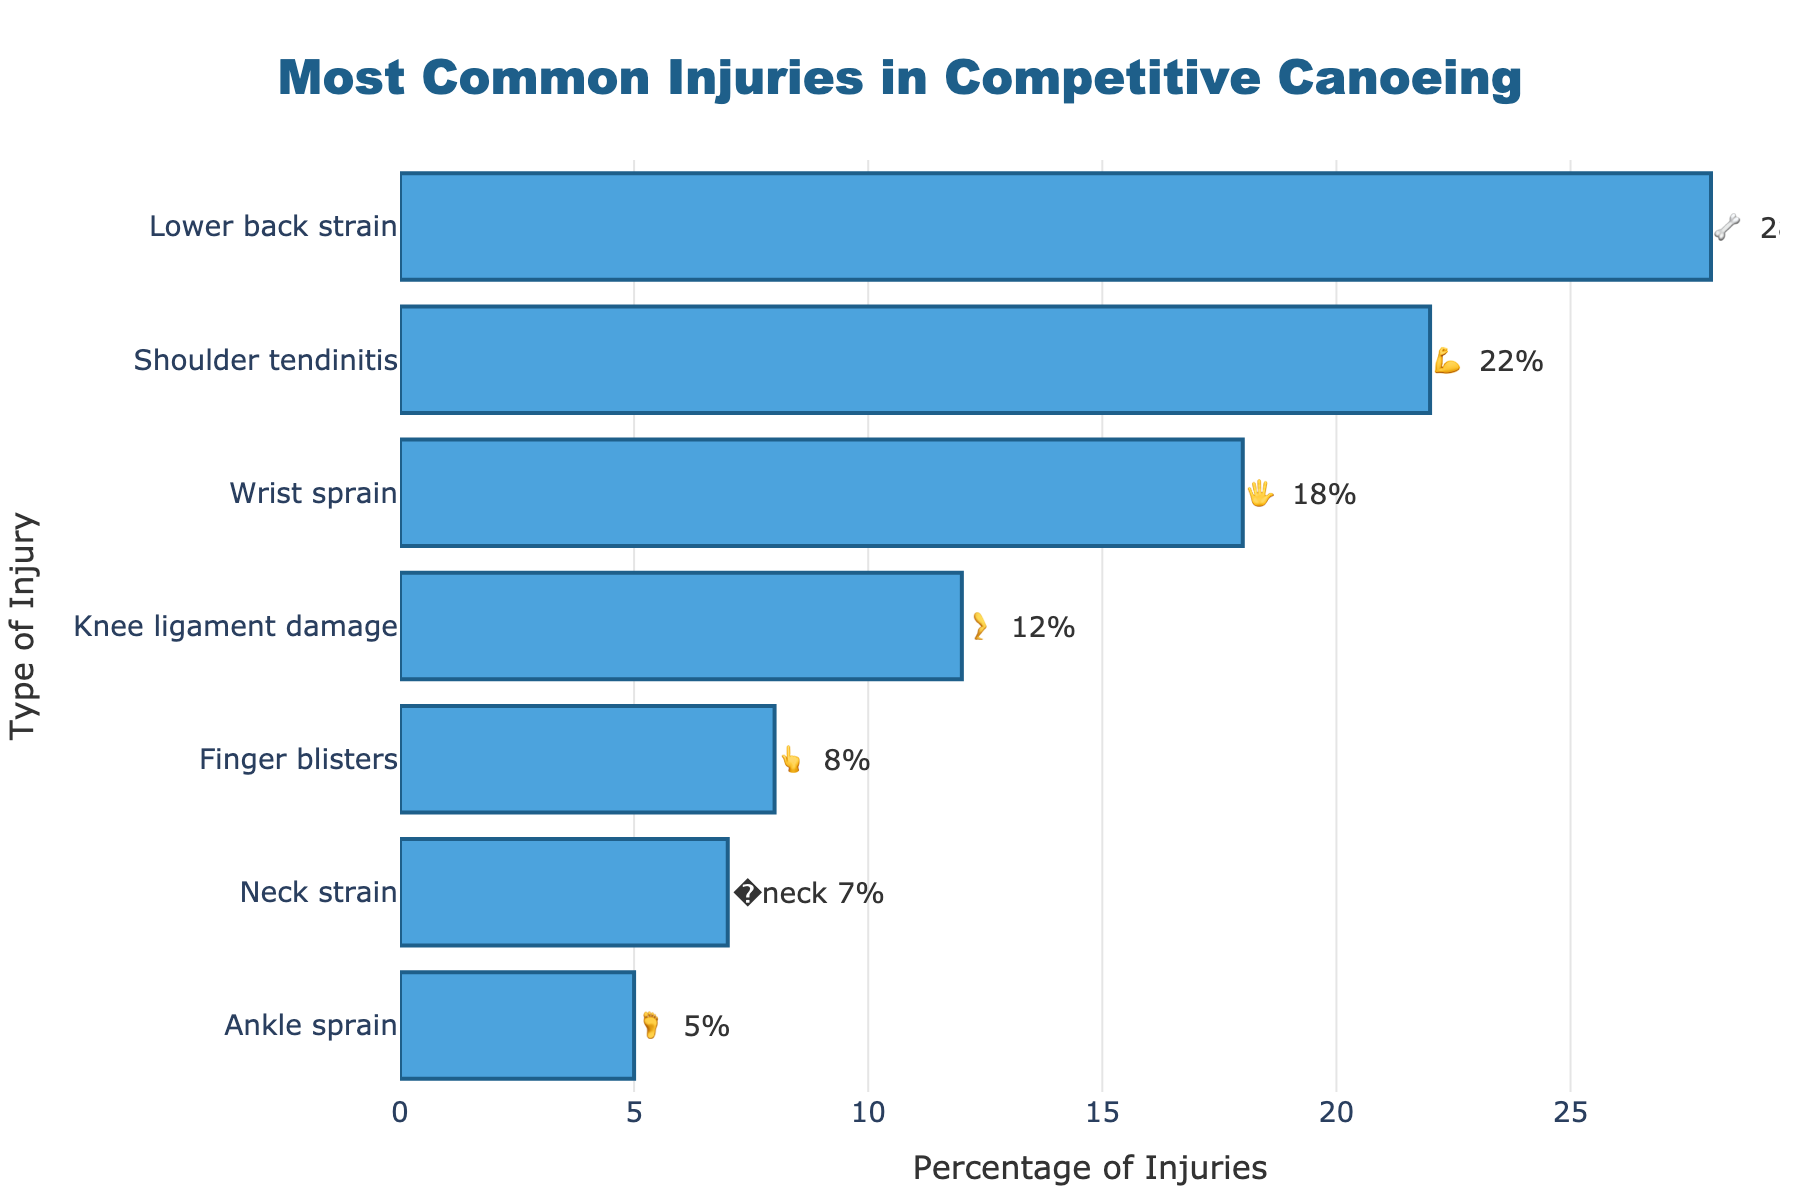What is the title of the chart? The title is displayed at the top center of the chart in a larger font size. It states the main topic of the visualization and is designated in bold and blue color.
Answer: Most Common Injuries in Competitive Canoeing Which injury has the highest percentage? Look for the bar with the greatest length on the horizontal bar chart and read the label next to it.
Answer: Lower back strain What percentage of injuries are shoulder tendinitis? Identify the bar labeled "Shoulder tendinitis" and read the percentage value associated with it.
Answer: 22% Which injury has the emoji 🔄️ next to it? There are no emojis in the provided data with the 🔄️ symbol associated, hence check for each injury and the corresponding emoji.
Answer: None How much higher is the percentage of Lower back strain compared to Wrist sprain? Find the percentages for Lower back strain and Wrist sprain, and then subtract the latter from the former (28% - 18%).
Answer: 10% What's the total percentage of injuries from Lower back strain and Shoulder tendinitis combined? Add the percentages of Lower back strain (28%) and Shoulder tendinitis (22%).
Answer: 50% Which injury involving the neck part emoji has the lowest percentage? Locate the bar with the neck part emoji 🦴 and identify its percentage. Then check if it's the lowest value displayed compared to others.
Answer: Ankle sprain (5%) How many types of injuries in this chart are identified? Count the number of different injury names listed on the y-axis.
Answer: Seven Which has a smaller percentage, Ankle sprain or Knee ligament damage? Compare the percentages of Ankle sprain (5%) and Knee ligament damage (12%).
Answer: Ankle sprain What is the average percentage of the top three most common injuries? Identify the top three percentages (28%, 22%, 18%), add them together, and then divide by 3 to get the average. (28 + 22 + 18) / 3
Answer: 22.67 